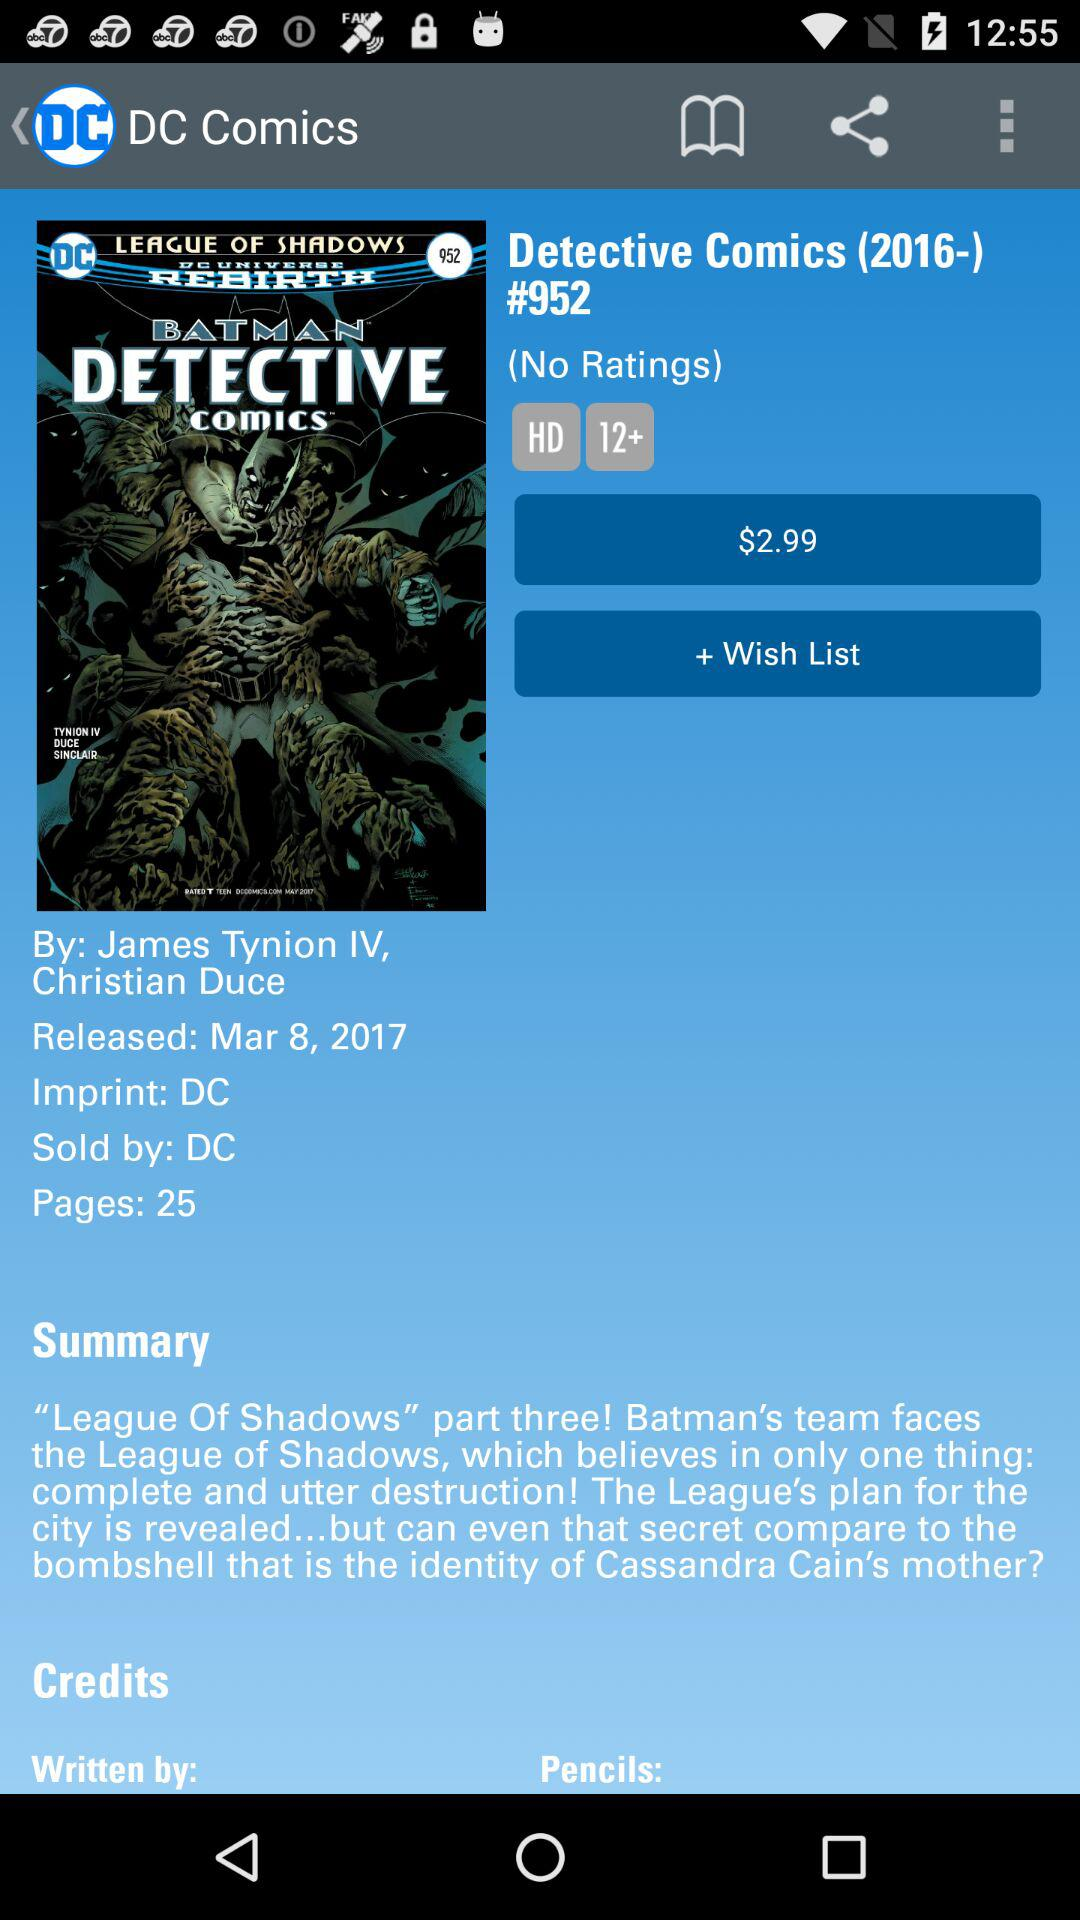What is the name of the application? The name of the application is "DC Comics". 